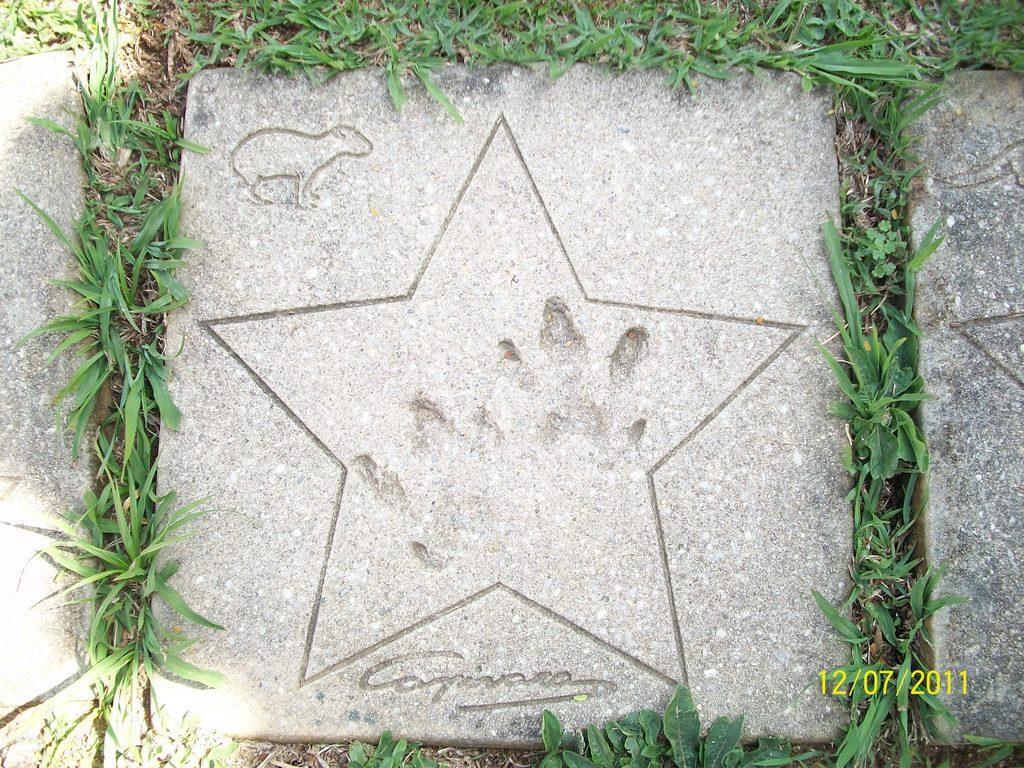Please provide a concise description of this image. In this picture there is a stone tile on the ground. In four sides of the stone, there is grass. On the stone, there is a star, fingerprints and an animal engraved on it. 